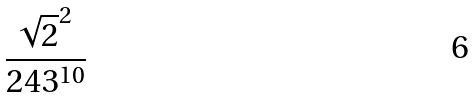<formula> <loc_0><loc_0><loc_500><loc_500>\frac { \sqrt { 2 } ^ { 2 } } { 2 4 3 ^ { 1 0 } }</formula> 